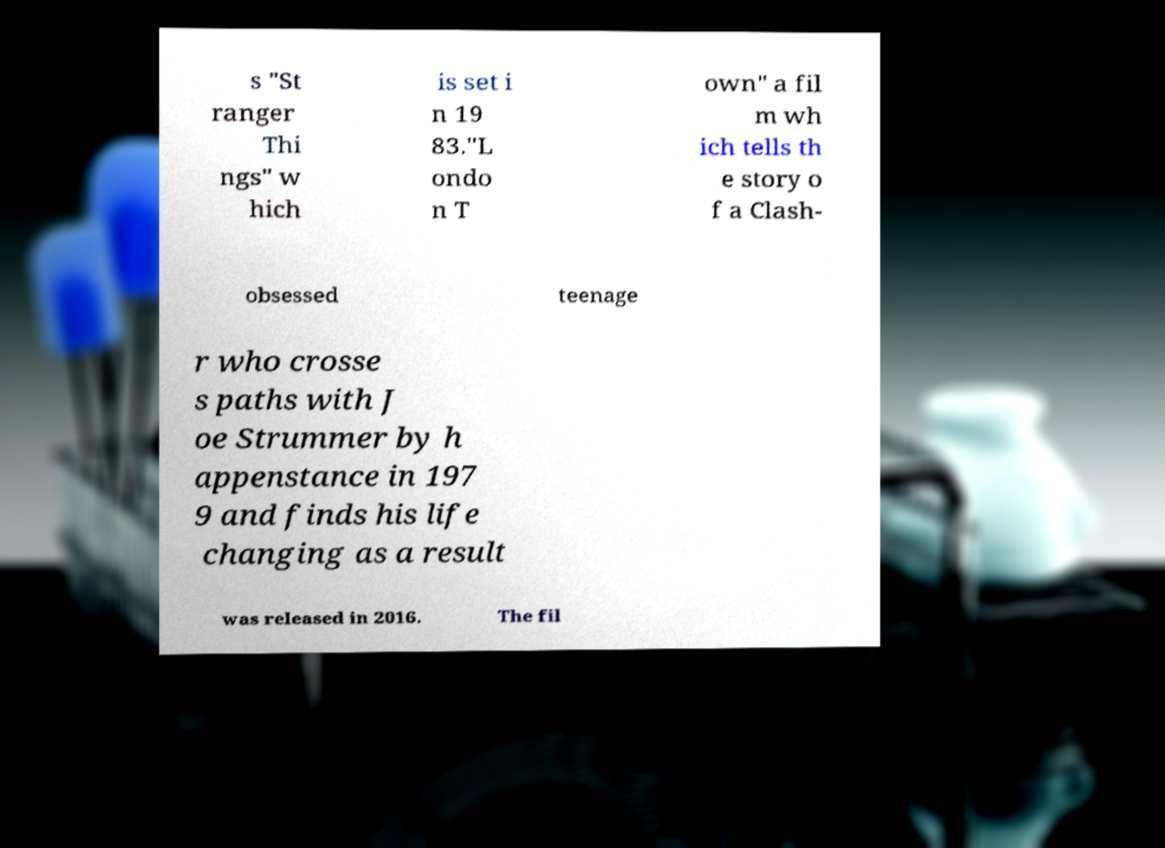There's text embedded in this image that I need extracted. Can you transcribe it verbatim? s "St ranger Thi ngs" w hich is set i n 19 83."L ondo n T own" a fil m wh ich tells th e story o f a Clash- obsessed teenage r who crosse s paths with J oe Strummer by h appenstance in 197 9 and finds his life changing as a result was released in 2016. The fil 